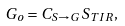<formula> <loc_0><loc_0><loc_500><loc_500>G _ { o } = C _ { S \rightarrow G } \, S _ { T I R } ,</formula> 